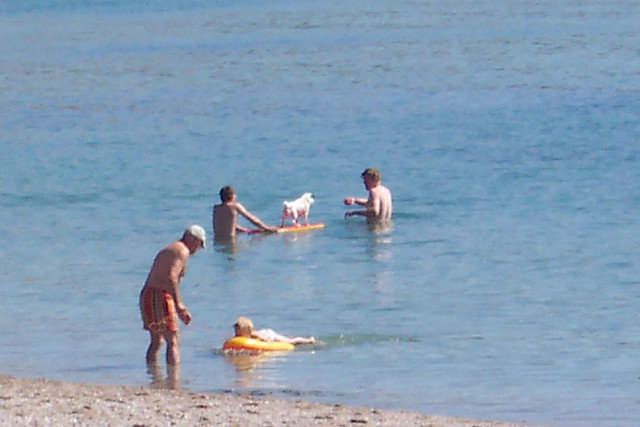Describe the objects in this image and their specific colors. I can see people in gray, brown, maroon, and purple tones, people in gray, purple, and darkgray tones, people in gray, lightgray, purple, and lightpink tones, dog in gray, white, brown, lightpink, and darkgray tones, and surfboard in gray, lightpink, and darkgray tones in this image. 